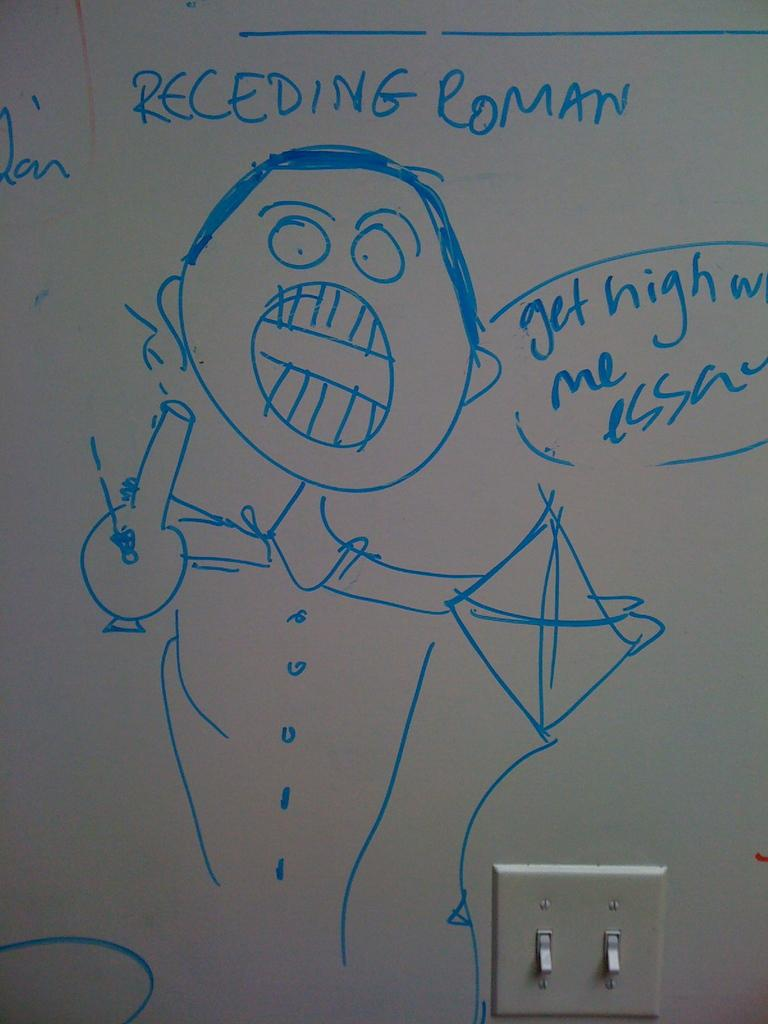Provide a one-sentence caption for the provided image. someone drew a picture on the white board of a man getting high. 